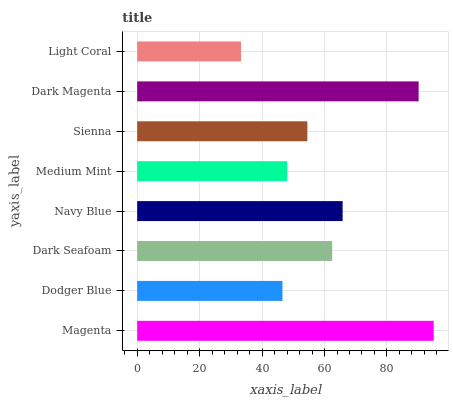Is Light Coral the minimum?
Answer yes or no. Yes. Is Magenta the maximum?
Answer yes or no. Yes. Is Dodger Blue the minimum?
Answer yes or no. No. Is Dodger Blue the maximum?
Answer yes or no. No. Is Magenta greater than Dodger Blue?
Answer yes or no. Yes. Is Dodger Blue less than Magenta?
Answer yes or no. Yes. Is Dodger Blue greater than Magenta?
Answer yes or no. No. Is Magenta less than Dodger Blue?
Answer yes or no. No. Is Dark Seafoam the high median?
Answer yes or no. Yes. Is Sienna the low median?
Answer yes or no. Yes. Is Navy Blue the high median?
Answer yes or no. No. Is Navy Blue the low median?
Answer yes or no. No. 